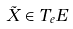Convert formula to latex. <formula><loc_0><loc_0><loc_500><loc_500>\tilde { X } \in T _ { e } E</formula> 